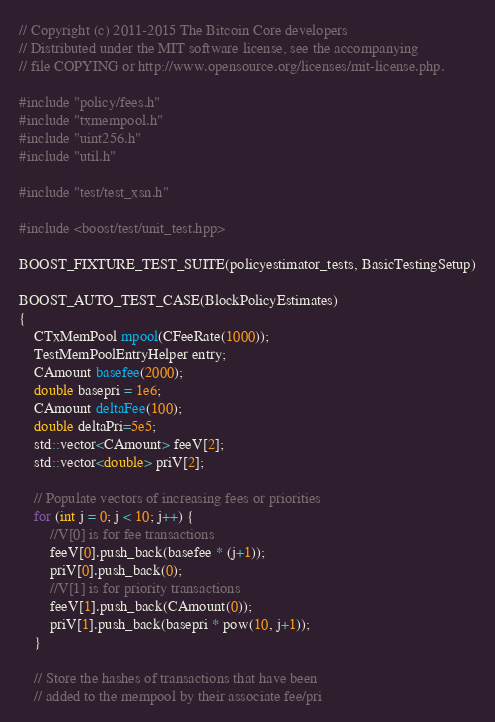Convert code to text. <code><loc_0><loc_0><loc_500><loc_500><_C++_>// Copyright (c) 2011-2015 The Bitcoin Core developers
// Distributed under the MIT software license, see the accompanying
// file COPYING or http://www.opensource.org/licenses/mit-license.php.

#include "policy/fees.h"
#include "txmempool.h"
#include "uint256.h"
#include "util.h"

#include "test/test_xsn.h"

#include <boost/test/unit_test.hpp>

BOOST_FIXTURE_TEST_SUITE(policyestimator_tests, BasicTestingSetup)

BOOST_AUTO_TEST_CASE(BlockPolicyEstimates)
{
    CTxMemPool mpool(CFeeRate(1000));
    TestMemPoolEntryHelper entry;
    CAmount basefee(2000);
    double basepri = 1e6;
    CAmount deltaFee(100);
    double deltaPri=5e5;
    std::vector<CAmount> feeV[2];
    std::vector<double> priV[2];

    // Populate vectors of increasing fees or priorities
    for (int j = 0; j < 10; j++) {
        //V[0] is for fee transactions
        feeV[0].push_back(basefee * (j+1));
        priV[0].push_back(0);
        //V[1] is for priority transactions
        feeV[1].push_back(CAmount(0));
        priV[1].push_back(basepri * pow(10, j+1));
    }

    // Store the hashes of transactions that have been
    // added to the mempool by their associate fee/pri</code> 